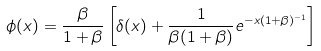<formula> <loc_0><loc_0><loc_500><loc_500>\phi ( x ) = \frac { \beta } { 1 + \beta } \left [ \delta ( x ) + \frac { 1 } { \beta ( 1 + \beta ) } e ^ { - x ( 1 + \beta ) ^ { - 1 } } \right ]</formula> 